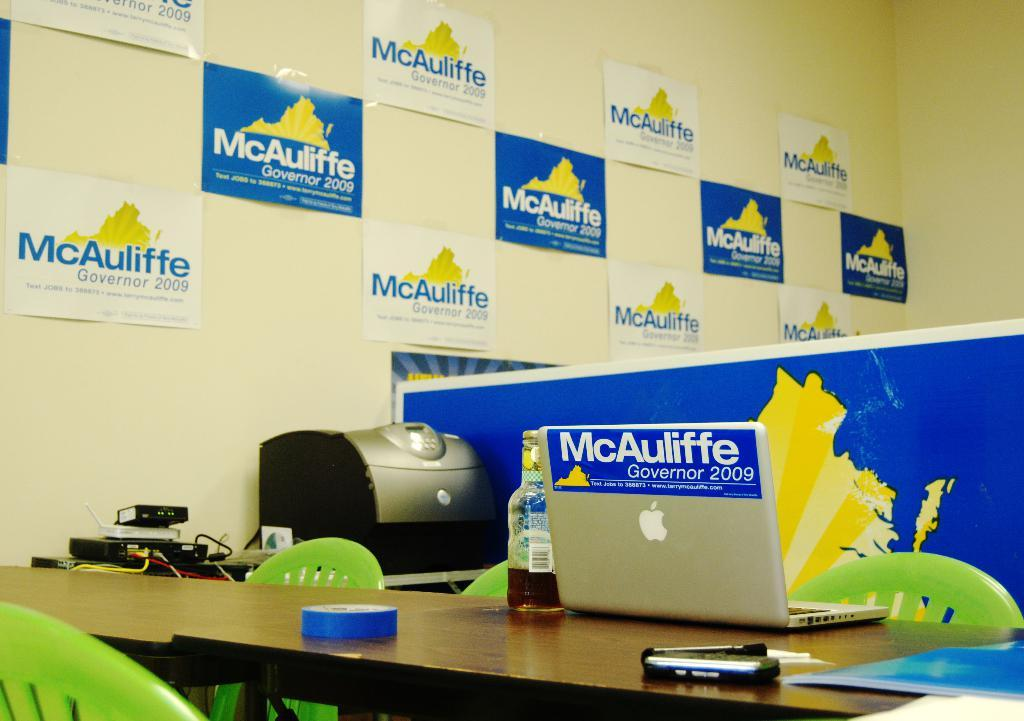Provide a one-sentence caption for the provided image. 2006 governor campaign office for larry mcauliffe with bumper sticker on back of apple laptop. 